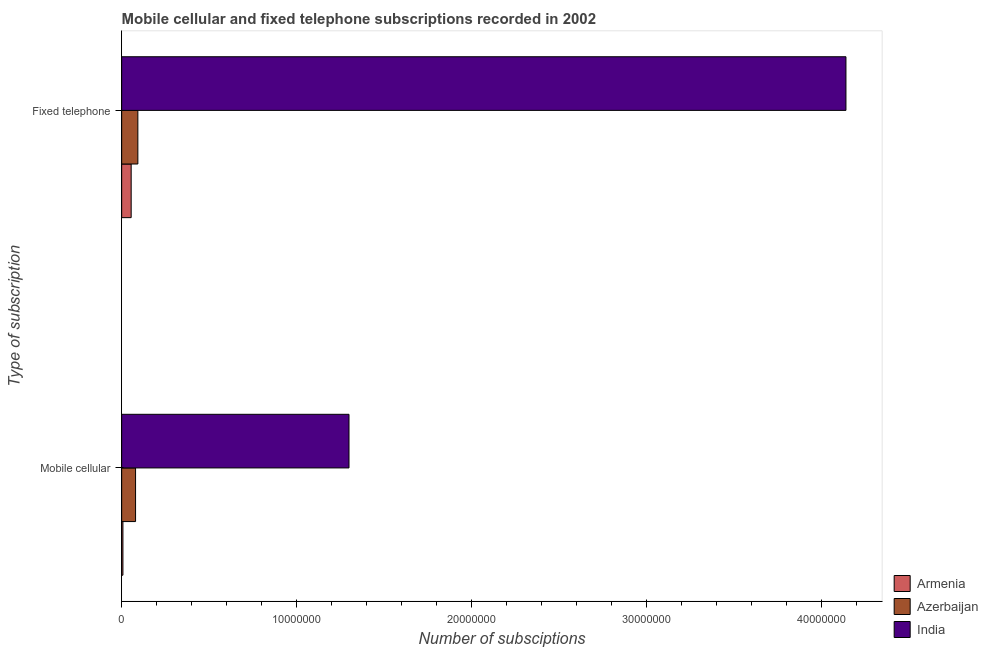How many different coloured bars are there?
Ensure brevity in your answer.  3. How many groups of bars are there?
Ensure brevity in your answer.  2. How many bars are there on the 2nd tick from the bottom?
Your answer should be very brief. 3. What is the label of the 1st group of bars from the top?
Give a very brief answer. Fixed telephone. What is the number of mobile cellular subscriptions in Armenia?
Provide a short and direct response. 7.13e+04. Across all countries, what is the maximum number of fixed telephone subscriptions?
Your answer should be compact. 4.14e+07. Across all countries, what is the minimum number of mobile cellular subscriptions?
Give a very brief answer. 7.13e+04. In which country was the number of fixed telephone subscriptions minimum?
Your answer should be very brief. Armenia. What is the total number of mobile cellular subscriptions in the graph?
Your answer should be very brief. 1.39e+07. What is the difference between the number of mobile cellular subscriptions in Armenia and that in India?
Make the answer very short. -1.29e+07. What is the difference between the number of fixed telephone subscriptions in Armenia and the number of mobile cellular subscriptions in Azerbaijan?
Keep it short and to the point. -2.51e+05. What is the average number of fixed telephone subscriptions per country?
Ensure brevity in your answer.  1.43e+07. What is the difference between the number of fixed telephone subscriptions and number of mobile cellular subscriptions in Azerbaijan?
Provide a short and direct response. 1.32e+05. In how many countries, is the number of mobile cellular subscriptions greater than 30000000 ?
Ensure brevity in your answer.  0. What is the ratio of the number of mobile cellular subscriptions in India to that in Armenia?
Offer a terse response. 182.2. What does the 2nd bar from the top in Mobile cellular represents?
Give a very brief answer. Azerbaijan. What does the 2nd bar from the bottom in Mobile cellular represents?
Make the answer very short. Azerbaijan. How many countries are there in the graph?
Provide a succinct answer. 3. What is the difference between two consecutive major ticks on the X-axis?
Your answer should be compact. 1.00e+07. Are the values on the major ticks of X-axis written in scientific E-notation?
Give a very brief answer. No. Does the graph contain grids?
Ensure brevity in your answer.  No. Where does the legend appear in the graph?
Make the answer very short. Bottom right. What is the title of the graph?
Ensure brevity in your answer.  Mobile cellular and fixed telephone subscriptions recorded in 2002. Does "Suriname" appear as one of the legend labels in the graph?
Your response must be concise. No. What is the label or title of the X-axis?
Provide a short and direct response. Number of subsciptions. What is the label or title of the Y-axis?
Your answer should be very brief. Type of subscription. What is the Number of subsciptions of Armenia in Mobile cellular?
Make the answer very short. 7.13e+04. What is the Number of subsciptions of Azerbaijan in Mobile cellular?
Ensure brevity in your answer.  7.94e+05. What is the Number of subsciptions in India in Mobile cellular?
Offer a terse response. 1.30e+07. What is the Number of subsciptions of Armenia in Fixed telephone?
Your answer should be very brief. 5.43e+05. What is the Number of subsciptions in Azerbaijan in Fixed telephone?
Your response must be concise. 9.26e+05. What is the Number of subsciptions in India in Fixed telephone?
Provide a succinct answer. 4.14e+07. Across all Type of subscription, what is the maximum Number of subsciptions in Armenia?
Your answer should be very brief. 5.43e+05. Across all Type of subscription, what is the maximum Number of subsciptions of Azerbaijan?
Ensure brevity in your answer.  9.26e+05. Across all Type of subscription, what is the maximum Number of subsciptions in India?
Keep it short and to the point. 4.14e+07. Across all Type of subscription, what is the minimum Number of subsciptions of Armenia?
Your response must be concise. 7.13e+04. Across all Type of subscription, what is the minimum Number of subsciptions of Azerbaijan?
Make the answer very short. 7.94e+05. Across all Type of subscription, what is the minimum Number of subsciptions of India?
Provide a succinct answer. 1.30e+07. What is the total Number of subsciptions in Armenia in the graph?
Make the answer very short. 6.14e+05. What is the total Number of subsciptions in Azerbaijan in the graph?
Your answer should be compact. 1.72e+06. What is the total Number of subsciptions in India in the graph?
Make the answer very short. 5.44e+07. What is the difference between the Number of subsciptions in Armenia in Mobile cellular and that in Fixed telephone?
Keep it short and to the point. -4.71e+05. What is the difference between the Number of subsciptions in Azerbaijan in Mobile cellular and that in Fixed telephone?
Your answer should be compact. -1.32e+05. What is the difference between the Number of subsciptions in India in Mobile cellular and that in Fixed telephone?
Provide a succinct answer. -2.84e+07. What is the difference between the Number of subsciptions in Armenia in Mobile cellular and the Number of subsciptions in Azerbaijan in Fixed telephone?
Offer a very short reply. -8.55e+05. What is the difference between the Number of subsciptions of Armenia in Mobile cellular and the Number of subsciptions of India in Fixed telephone?
Provide a short and direct response. -4.13e+07. What is the difference between the Number of subsciptions in Azerbaijan in Mobile cellular and the Number of subsciptions in India in Fixed telephone?
Ensure brevity in your answer.  -4.06e+07. What is the average Number of subsciptions of Armenia per Type of subscription?
Provide a short and direct response. 3.07e+05. What is the average Number of subsciptions in Azerbaijan per Type of subscription?
Ensure brevity in your answer.  8.60e+05. What is the average Number of subsciptions of India per Type of subscription?
Keep it short and to the point. 2.72e+07. What is the difference between the Number of subsciptions in Armenia and Number of subsciptions in Azerbaijan in Mobile cellular?
Provide a succinct answer. -7.23e+05. What is the difference between the Number of subsciptions in Armenia and Number of subsciptions in India in Mobile cellular?
Offer a very short reply. -1.29e+07. What is the difference between the Number of subsciptions in Azerbaijan and Number of subsciptions in India in Mobile cellular?
Make the answer very short. -1.22e+07. What is the difference between the Number of subsciptions in Armenia and Number of subsciptions in Azerbaijan in Fixed telephone?
Your answer should be very brief. -3.83e+05. What is the difference between the Number of subsciptions of Armenia and Number of subsciptions of India in Fixed telephone?
Keep it short and to the point. -4.09e+07. What is the difference between the Number of subsciptions of Azerbaijan and Number of subsciptions of India in Fixed telephone?
Keep it short and to the point. -4.05e+07. What is the ratio of the Number of subsciptions of Armenia in Mobile cellular to that in Fixed telephone?
Offer a very short reply. 0.13. What is the ratio of the Number of subsciptions of Azerbaijan in Mobile cellular to that in Fixed telephone?
Your answer should be compact. 0.86. What is the ratio of the Number of subsciptions in India in Mobile cellular to that in Fixed telephone?
Keep it short and to the point. 0.31. What is the difference between the highest and the second highest Number of subsciptions of Armenia?
Provide a succinct answer. 4.71e+05. What is the difference between the highest and the second highest Number of subsciptions in Azerbaijan?
Offer a very short reply. 1.32e+05. What is the difference between the highest and the second highest Number of subsciptions of India?
Give a very brief answer. 2.84e+07. What is the difference between the highest and the lowest Number of subsciptions in Armenia?
Give a very brief answer. 4.71e+05. What is the difference between the highest and the lowest Number of subsciptions in Azerbaijan?
Give a very brief answer. 1.32e+05. What is the difference between the highest and the lowest Number of subsciptions of India?
Offer a terse response. 2.84e+07. 